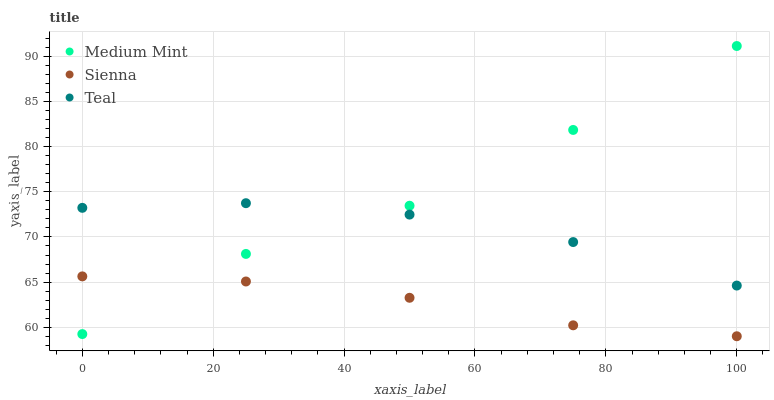Does Sienna have the minimum area under the curve?
Answer yes or no. Yes. Does Medium Mint have the maximum area under the curve?
Answer yes or no. Yes. Does Teal have the minimum area under the curve?
Answer yes or no. No. Does Teal have the maximum area under the curve?
Answer yes or no. No. Is Sienna the smoothest?
Answer yes or no. Yes. Is Medium Mint the roughest?
Answer yes or no. Yes. Is Teal the smoothest?
Answer yes or no. No. Is Teal the roughest?
Answer yes or no. No. Does Sienna have the lowest value?
Answer yes or no. Yes. Does Teal have the lowest value?
Answer yes or no. No. Does Medium Mint have the highest value?
Answer yes or no. Yes. Does Teal have the highest value?
Answer yes or no. No. Is Sienna less than Teal?
Answer yes or no. Yes. Is Teal greater than Sienna?
Answer yes or no. Yes. Does Medium Mint intersect Sienna?
Answer yes or no. Yes. Is Medium Mint less than Sienna?
Answer yes or no. No. Is Medium Mint greater than Sienna?
Answer yes or no. No. Does Sienna intersect Teal?
Answer yes or no. No. 